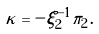Convert formula to latex. <formula><loc_0><loc_0><loc_500><loc_500>\kappa = - \xi _ { 2 } ^ { - 1 } \pi _ { 2 } \, .</formula> 